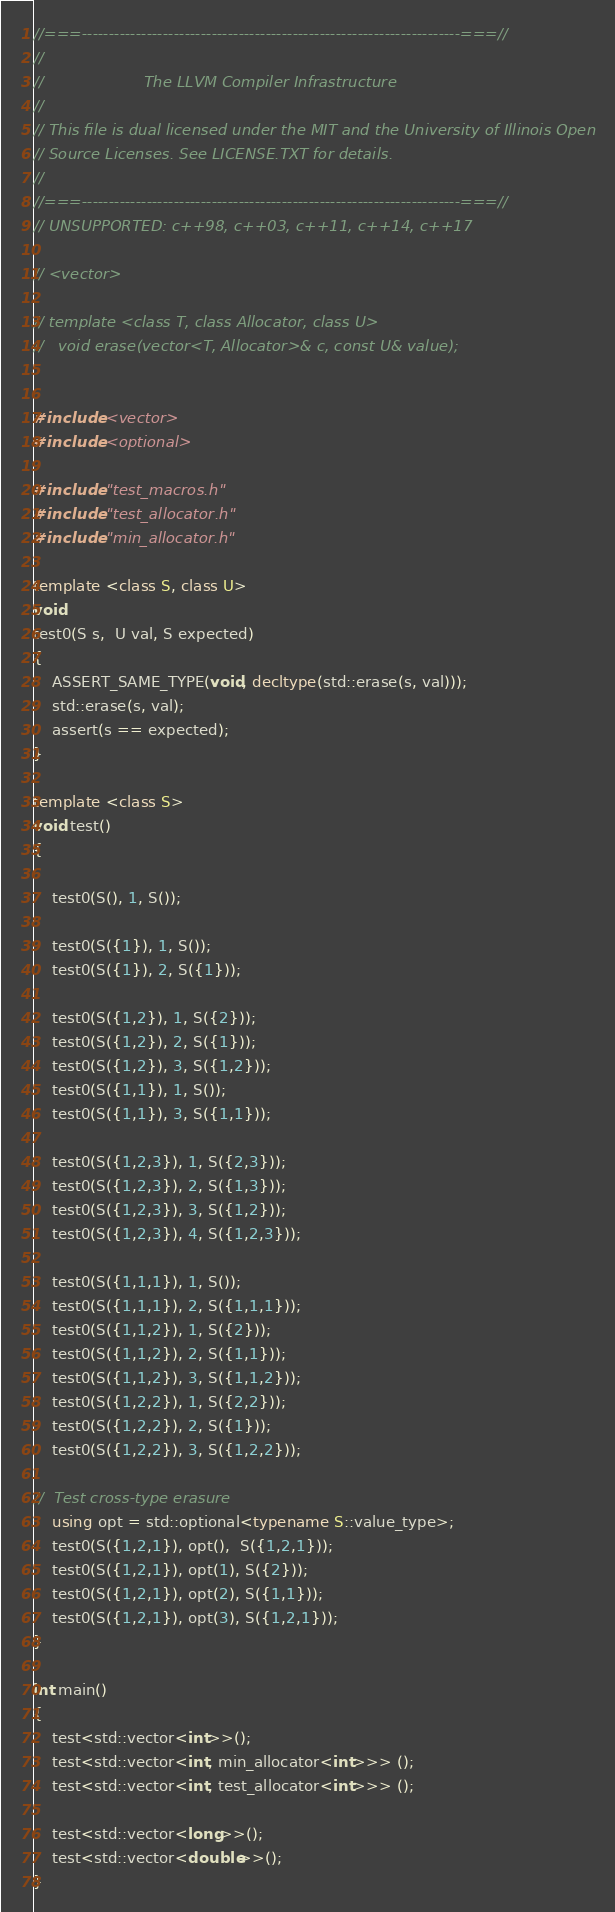<code> <loc_0><loc_0><loc_500><loc_500><_C++_>//===----------------------------------------------------------------------===//
//
//                     The LLVM Compiler Infrastructure
//
// This file is dual licensed under the MIT and the University of Illinois Open
// Source Licenses. See LICENSE.TXT for details.
//
//===----------------------------------------------------------------------===//
// UNSUPPORTED: c++98, c++03, c++11, c++14, c++17

// <vector>

// template <class T, class Allocator, class U>
//   void erase(vector<T, Allocator>& c, const U& value);
  

#include <vector>
#include <optional>

#include "test_macros.h"
#include "test_allocator.h"
#include "min_allocator.h"

template <class S, class U>
void
test0(S s,  U val, S expected)
{
    ASSERT_SAME_TYPE(void, decltype(std::erase(s, val)));
    std::erase(s, val);
    assert(s == expected);
}

template <class S>
void test()
{

    test0(S(), 1, S());

    test0(S({1}), 1, S());
    test0(S({1}), 2, S({1}));

    test0(S({1,2}), 1, S({2}));
    test0(S({1,2}), 2, S({1}));
    test0(S({1,2}), 3, S({1,2}));
    test0(S({1,1}), 1, S());
    test0(S({1,1}), 3, S({1,1}));

    test0(S({1,2,3}), 1, S({2,3}));
    test0(S({1,2,3}), 2, S({1,3}));
    test0(S({1,2,3}), 3, S({1,2}));
    test0(S({1,2,3}), 4, S({1,2,3}));

    test0(S({1,1,1}), 1, S());
    test0(S({1,1,1}), 2, S({1,1,1}));
    test0(S({1,1,2}), 1, S({2}));
    test0(S({1,1,2}), 2, S({1,1}));
    test0(S({1,1,2}), 3, S({1,1,2}));
    test0(S({1,2,2}), 1, S({2,2}));
    test0(S({1,2,2}), 2, S({1}));
    test0(S({1,2,2}), 3, S({1,2,2}));

//  Test cross-type erasure
    using opt = std::optional<typename S::value_type>;
    test0(S({1,2,1}), opt(),  S({1,2,1}));
    test0(S({1,2,1}), opt(1), S({2}));
    test0(S({1,2,1}), opt(2), S({1,1}));
    test0(S({1,2,1}), opt(3), S({1,2,1}));
}

int main()
{
    test<std::vector<int>>();
    test<std::vector<int, min_allocator<int>>> ();
    test<std::vector<int, test_allocator<int>>> ();

    test<std::vector<long>>();
    test<std::vector<double>>();
}
</code> 